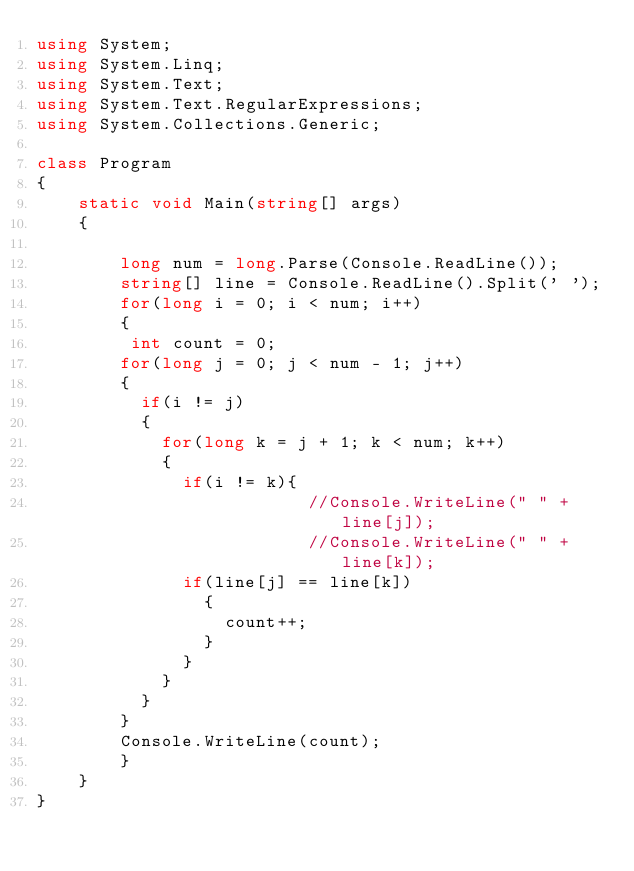<code> <loc_0><loc_0><loc_500><loc_500><_C#_>using System;
using System.Linq;
using System.Text;
using System.Text.RegularExpressions;
using System.Collections.Generic;

class Program
{
    static void Main(string[] args)
    {

        long num = long.Parse(Console.ReadLine());
        string[] line = Console.ReadLine().Split(' ');
      	for(long i = 0; i < num; i++)
        {
         int count = 0;
        for(long j = 0; j < num - 1; j++)
        {
          if(i != j)
          {
          	for(long k = j + 1; k < num; k++)
          	{
              if(i != k){
                          //Console.WriteLine(" " + line[j]);  
                          //Console.WriteLine(" " + line[k]);  
          		if(line[j] == line[k])
                {
                  count++;
                }
              }
          	}
          }
        }
        Console.WriteLine(count);  
        }
    }
}</code> 